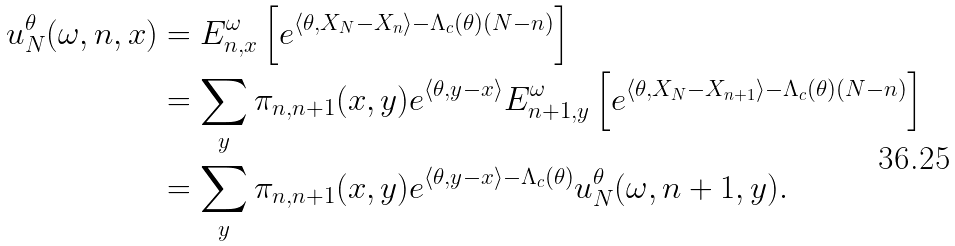<formula> <loc_0><loc_0><loc_500><loc_500>u _ { N } ^ { \theta } ( \omega , n , x ) & = E _ { n , x } ^ { \omega } \left [ e ^ { \langle \theta , X _ { N } - X _ { n } \rangle - \Lambda _ { c } ( \theta ) ( N - n ) } \right ] \\ & = \sum _ { y } \pi _ { n , n + 1 } ( x , y ) e ^ { \langle \theta , y - x \rangle } E _ { n + 1 , y } ^ { \omega } \left [ e ^ { \langle \theta , X _ { N } - X _ { n + 1 } \rangle - \Lambda _ { c } ( \theta ) ( N - n ) } \right ] \\ & = \sum _ { y } \pi _ { n , n + 1 } ( x , y ) e ^ { \langle \theta , y - x \rangle - \Lambda _ { c } ( \theta ) } u _ { N } ^ { \theta } ( \omega , n + 1 , y ) .</formula> 